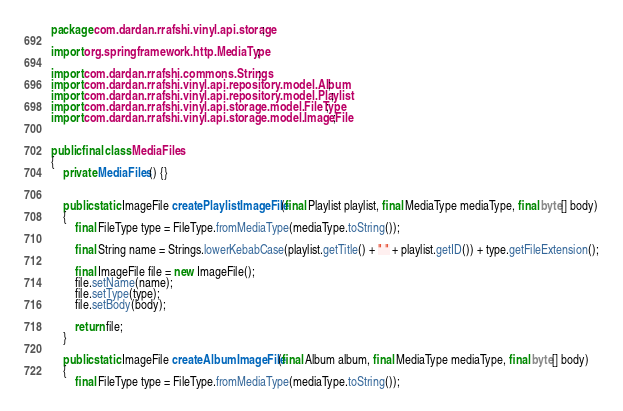<code> <loc_0><loc_0><loc_500><loc_500><_Java_>package com.dardan.rrafshi.vinyl.api.storage;

import org.springframework.http.MediaType;

import com.dardan.rrafshi.commons.Strings;
import com.dardan.rrafshi.vinyl.api.repository.model.Album;
import com.dardan.rrafshi.vinyl.api.repository.model.Playlist;
import com.dardan.rrafshi.vinyl.api.storage.model.FileType;
import com.dardan.rrafshi.vinyl.api.storage.model.ImageFile;


public final class MediaFiles
{
	private MediaFiles() {}


	public static ImageFile createPlaylistImageFile(final Playlist playlist, final MediaType mediaType, final byte[] body)
	{
		final FileType type = FileType.fromMediaType(mediaType.toString());

		final String name = Strings.lowerKebabCase(playlist.getTitle() + " " + playlist.getID()) + type.getFileExtension();

		final ImageFile file = new ImageFile();
		file.setName(name);
		file.setType(type);
		file.setBody(body);

		return file;
	}

	public static ImageFile createAlbumImageFile(final Album album, final MediaType mediaType, final byte[] body)
	{
		final FileType type = FileType.fromMediaType(mediaType.toString());
</code> 